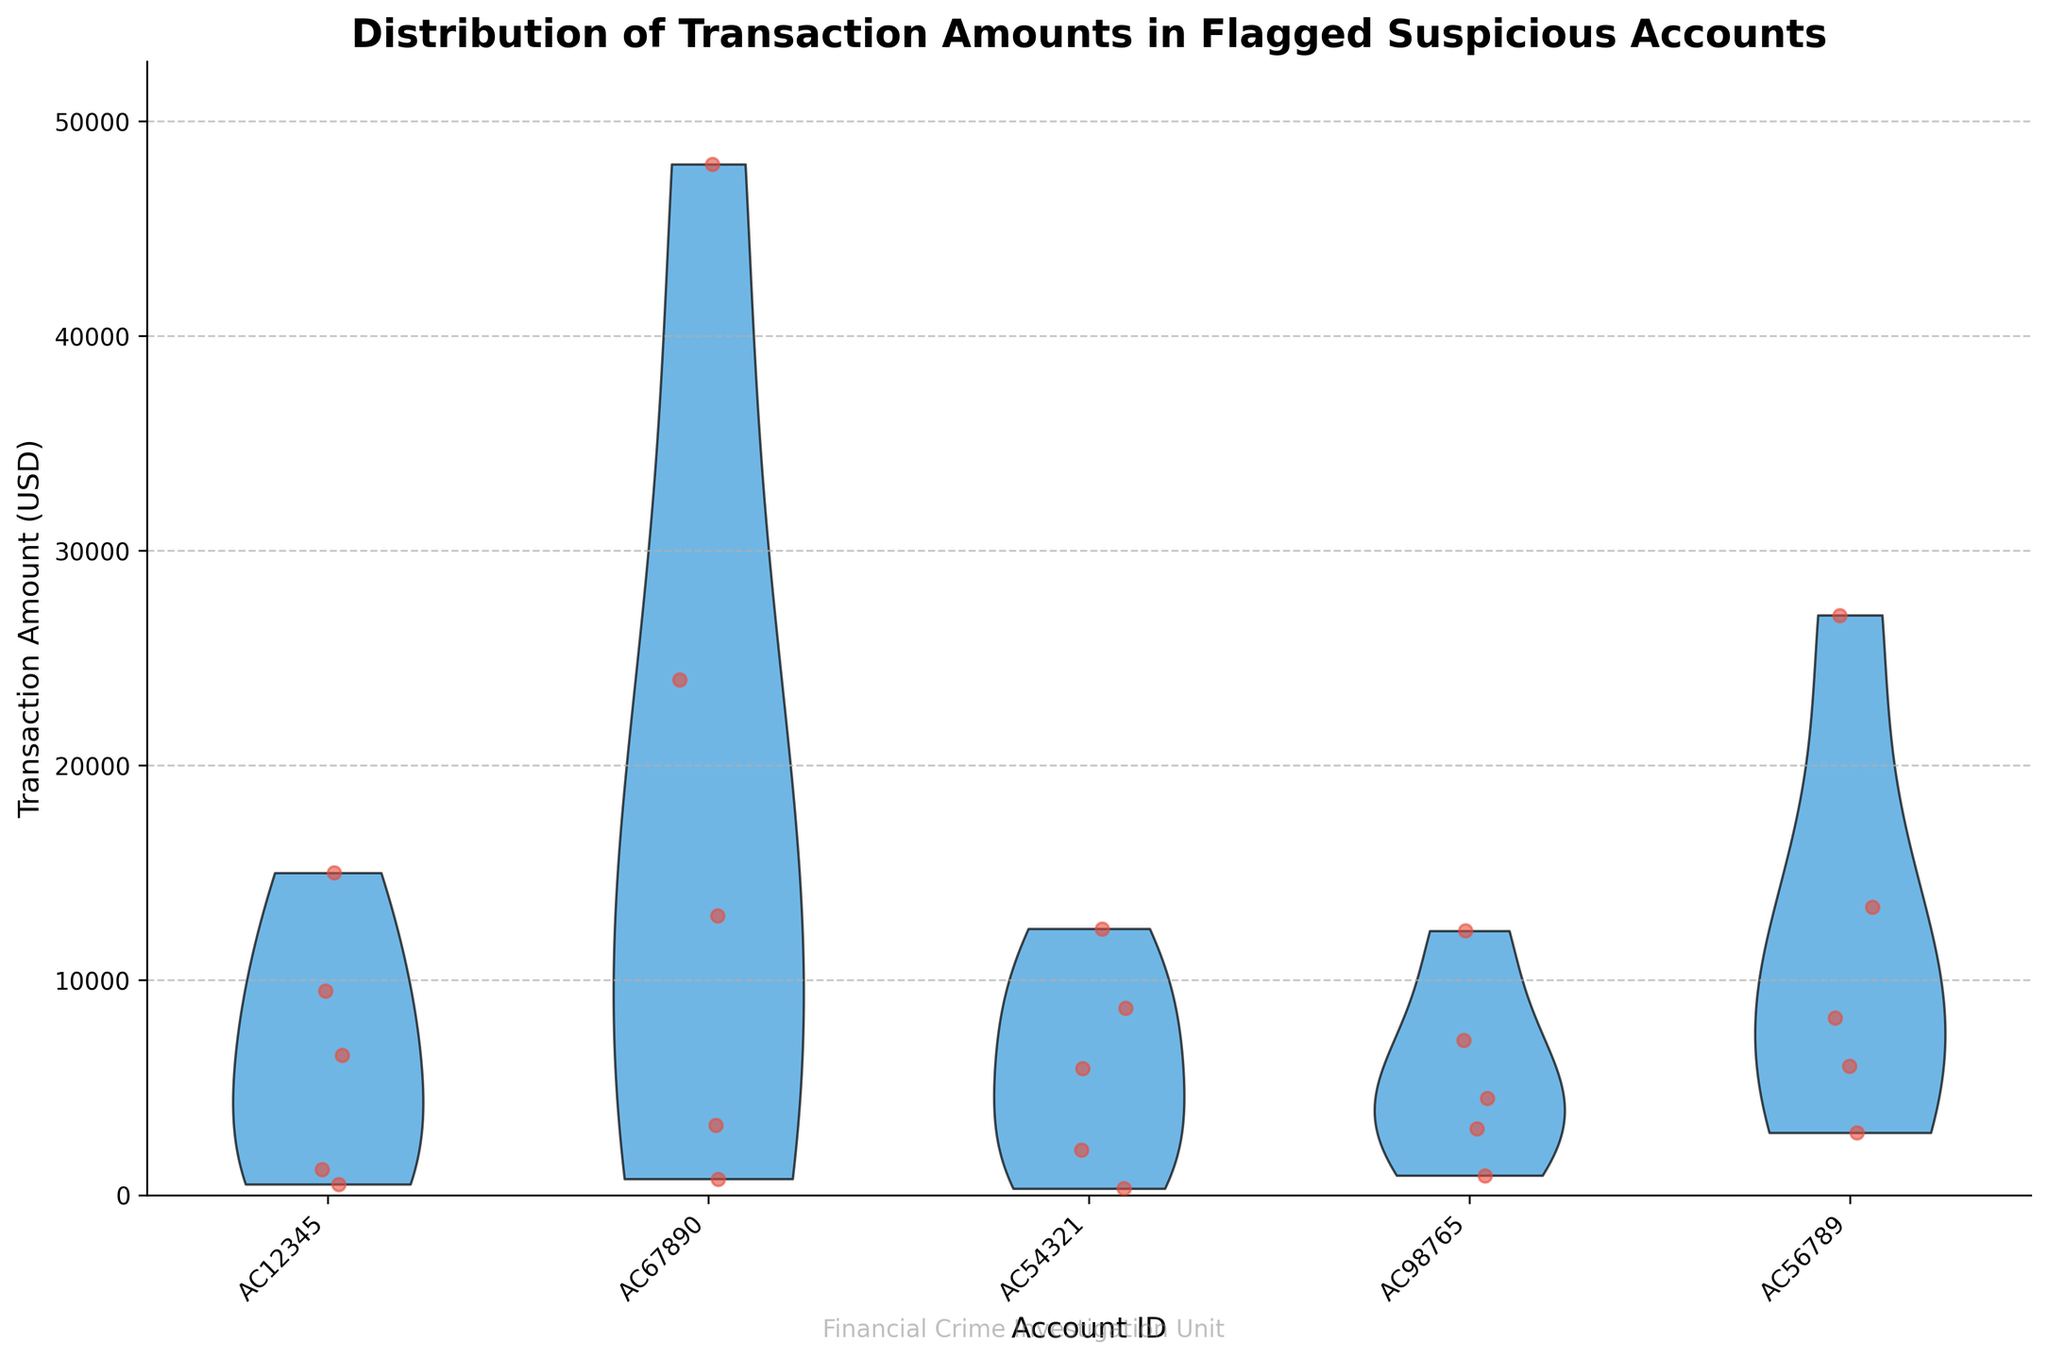Which account has the highest single transaction amount? The account with the highest single transaction amount is identified by comparing the maximum values represented for each account by examining the jittered points. From the plot, Account AC67890 shows the highest point, indicating it has the highest transaction amount.
Answer: AC67890 What is the range of transaction amounts for Account AC54321? The range of transaction amounts can be determined by noting the lowest and highest jittered points for AC54321. The lowest appears around $300 and the highest near $12400. Hence, the range is 12400 - 300 = 12100 USD.
Answer: 12100 USD Which account has the widest distribution of transaction amounts? To find the account with the widest distribution, we look at the spread of the violins and the jittered points. Account AC67890 shows a significantly wider spread than the others, indicating it has the widest distribution of transaction amounts.
Answer: AC67890 What is the median transaction value for Account AC98765? The median transaction value is found by noting the central tendency of the jittered points in the violin plot. The median for AC98765 appears around $4500 to $5000.
Answer: Around $4500 to $5000 Is there any account with a smaller variance in transaction amounts compared to others? By looking for the narrowest violin plot, we can determine the account with the smallest variance. Account AC98765 appears to have the smallest spread among the plotted accounts, indicating lower variance.
Answer: AC98765 How do the transaction amounts of Account AC56789 compare to Account AC12345? For a comparison, we observe both the central tendency and the spread. Both accounts have similarly high maximum values, but AC56789 has higher overall amounts with a broader spread compared to AC12345.
Answer: AC56789 generally has higher and more spread out amounts than AC12345 What is the average transaction amount for Account AC67890? To calculate the average, sum the transaction values and divide by the number of transactions. The sum for AC67890's transactions is 750 + 3250 + 48000 + 24000 + 13000 = 89000 USD. Dividing by 5 gives 89000/5 = 17800 USD.
Answer: 17800 USD Can you identify if there is an account that consistently has lower transaction amounts? Analyzing the jittered points and their placement, AC54321 seems to consistently show smaller values compared to the other accounts, except for some larger transactions.
Answer: AC54321 How does the distribution of Account AC67890 transactions stand out compared to others? AC67890 stands out with a very wide distribution and a diverse range of values, from low hundreds to tens of thousands, as shown by both its wide violin plot and spread out jittered points.
Answer: Diverse and wide distribution 